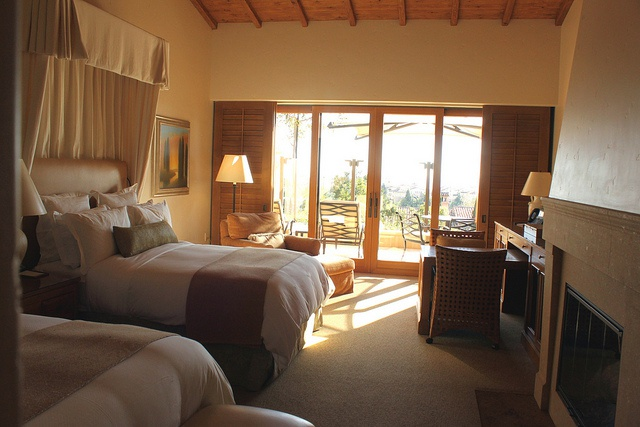Describe the objects in this image and their specific colors. I can see bed in black, maroon, gray, and darkgray tones, bed in black, maroon, and gray tones, chair in black, maroon, and gray tones, chair in black, brown, gray, maroon, and tan tones, and dining table in black, maroon, white, and darkgray tones in this image. 